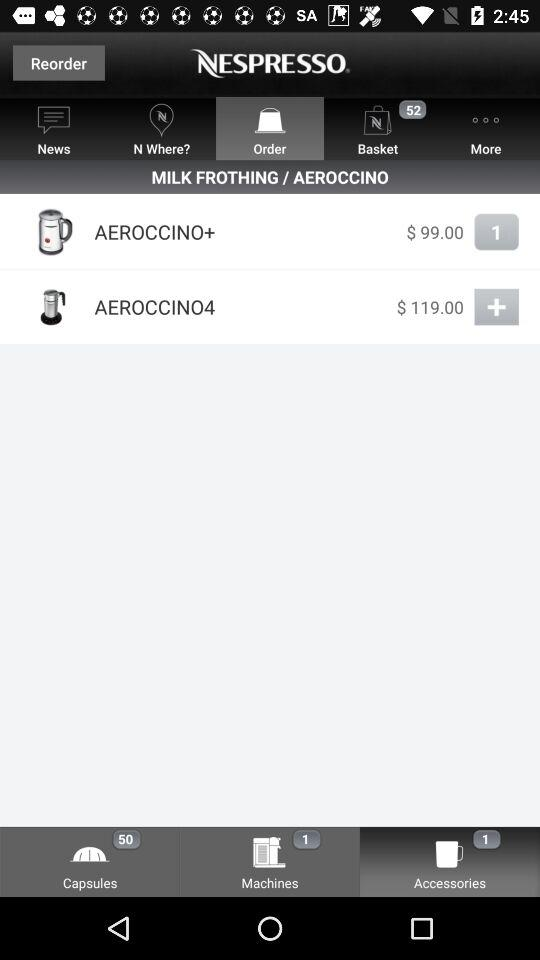What is the price of Aeroccino+? The price of Aeroccino+ is $99. 